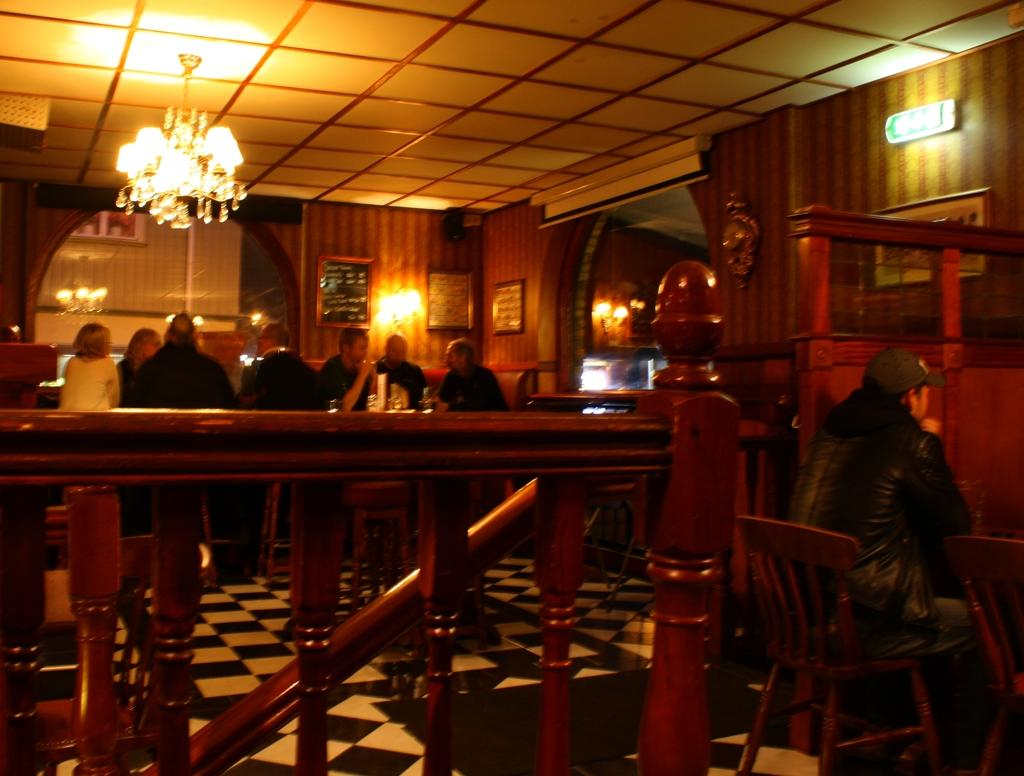What type of establishment is depicted in the image? The image is set in a restaurant. What are the people in the image doing? People are sitting on chairs in the image. What can be seen in the background of the image? There is a wall in the background of the image. What type of lighting fixture is present in the image? A chandelier is hanging from the roof in the image. What type of bone is visible on the table in the image? There is no bone visible on the table in the image. What expert is present in the image to provide advice on the menu? There is no expert present in the image to provide advice on the menu. 